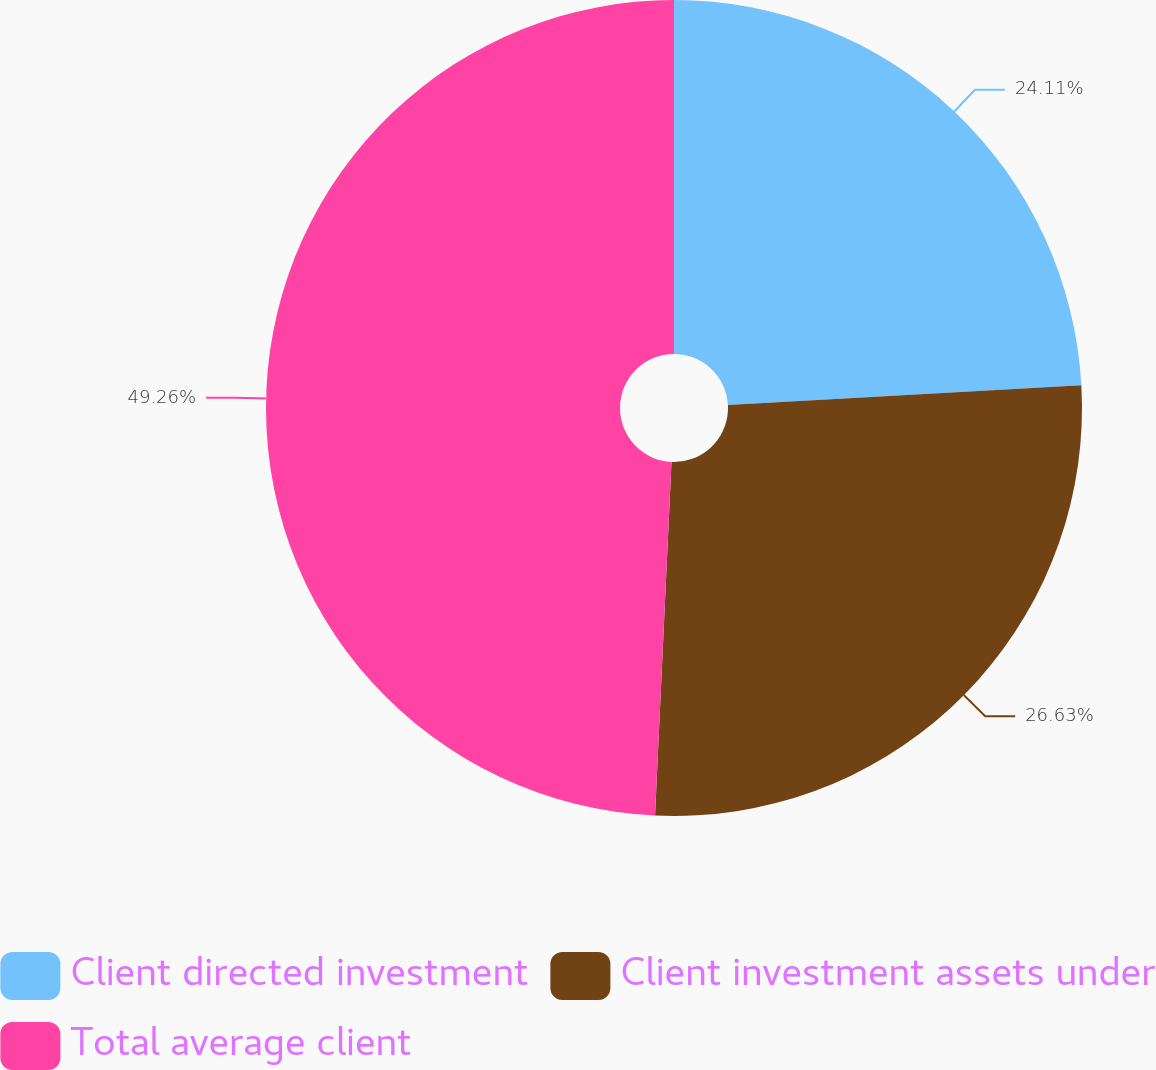Convert chart. <chart><loc_0><loc_0><loc_500><loc_500><pie_chart><fcel>Client directed investment<fcel>Client investment assets under<fcel>Total average client<nl><fcel>24.11%<fcel>26.63%<fcel>49.26%<nl></chart> 